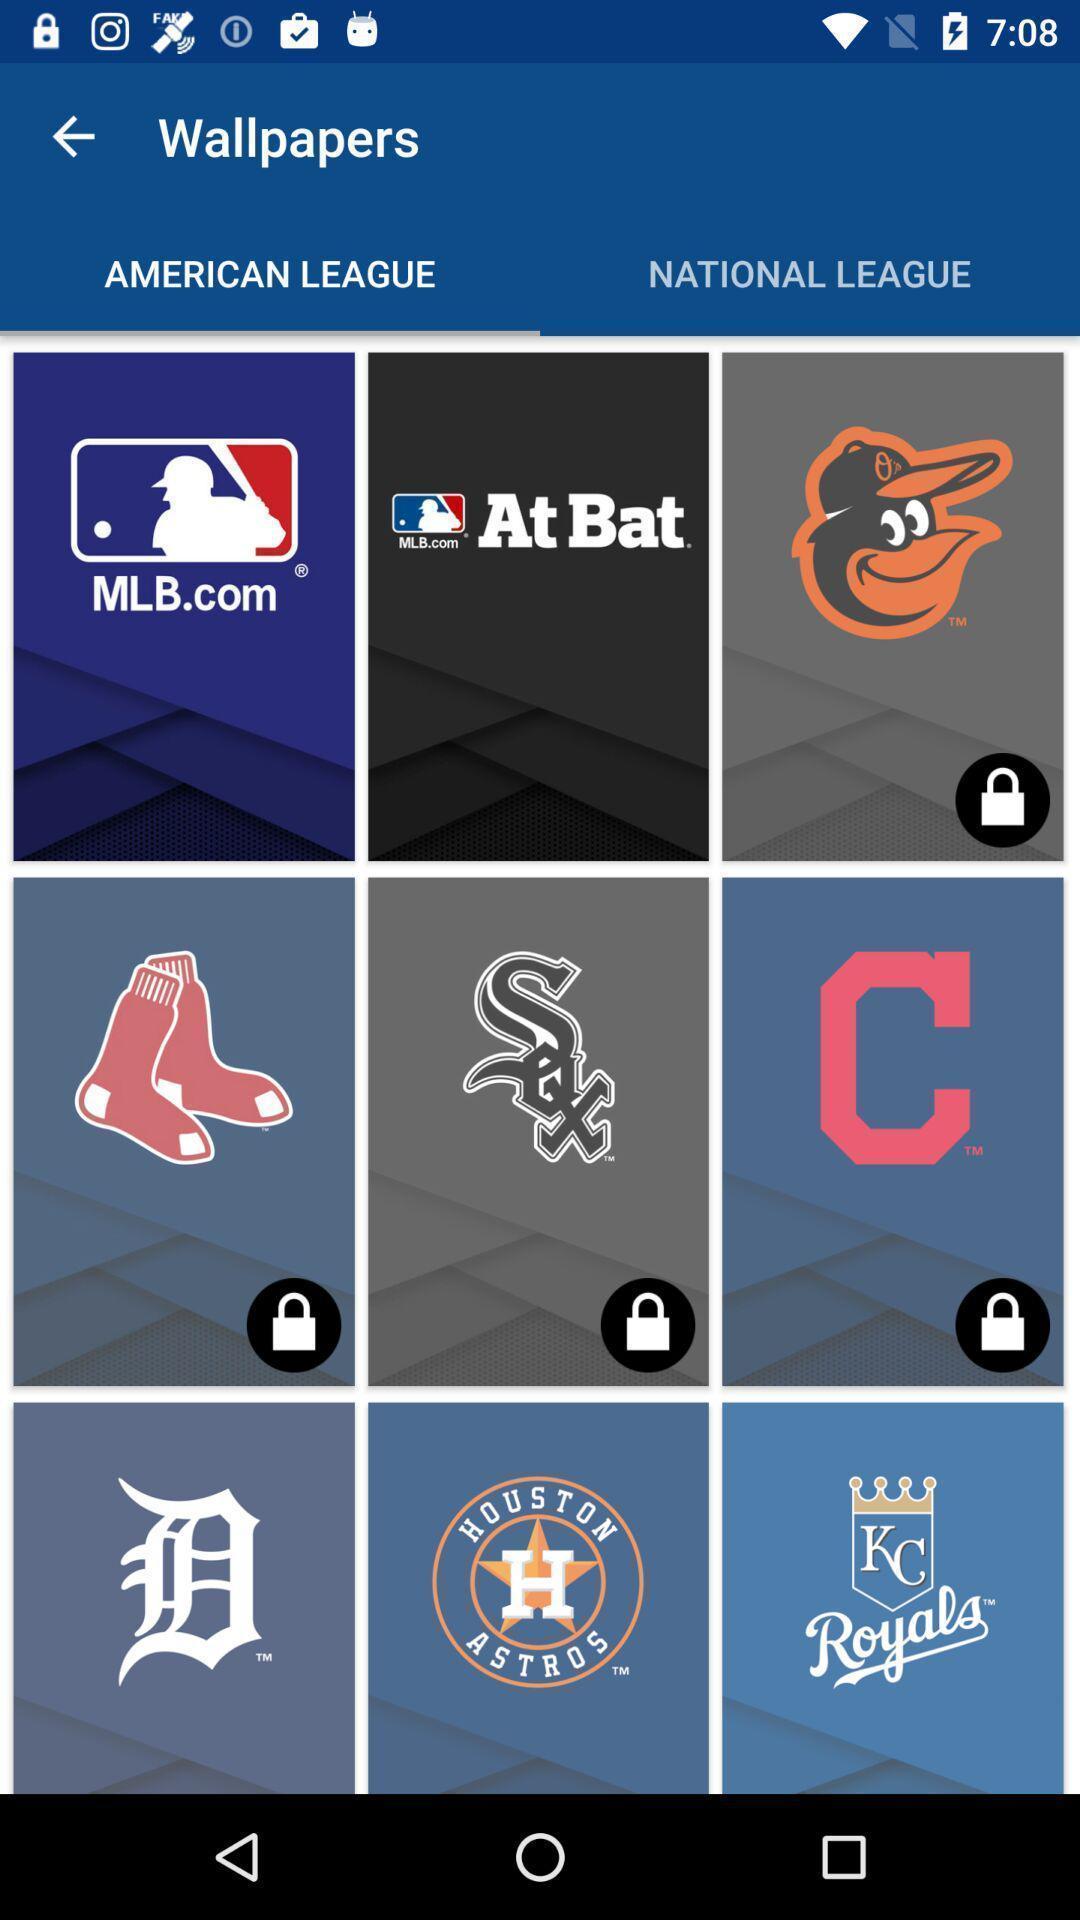What is the overall content of this screenshot? Screen shows wallpapers on a league. 